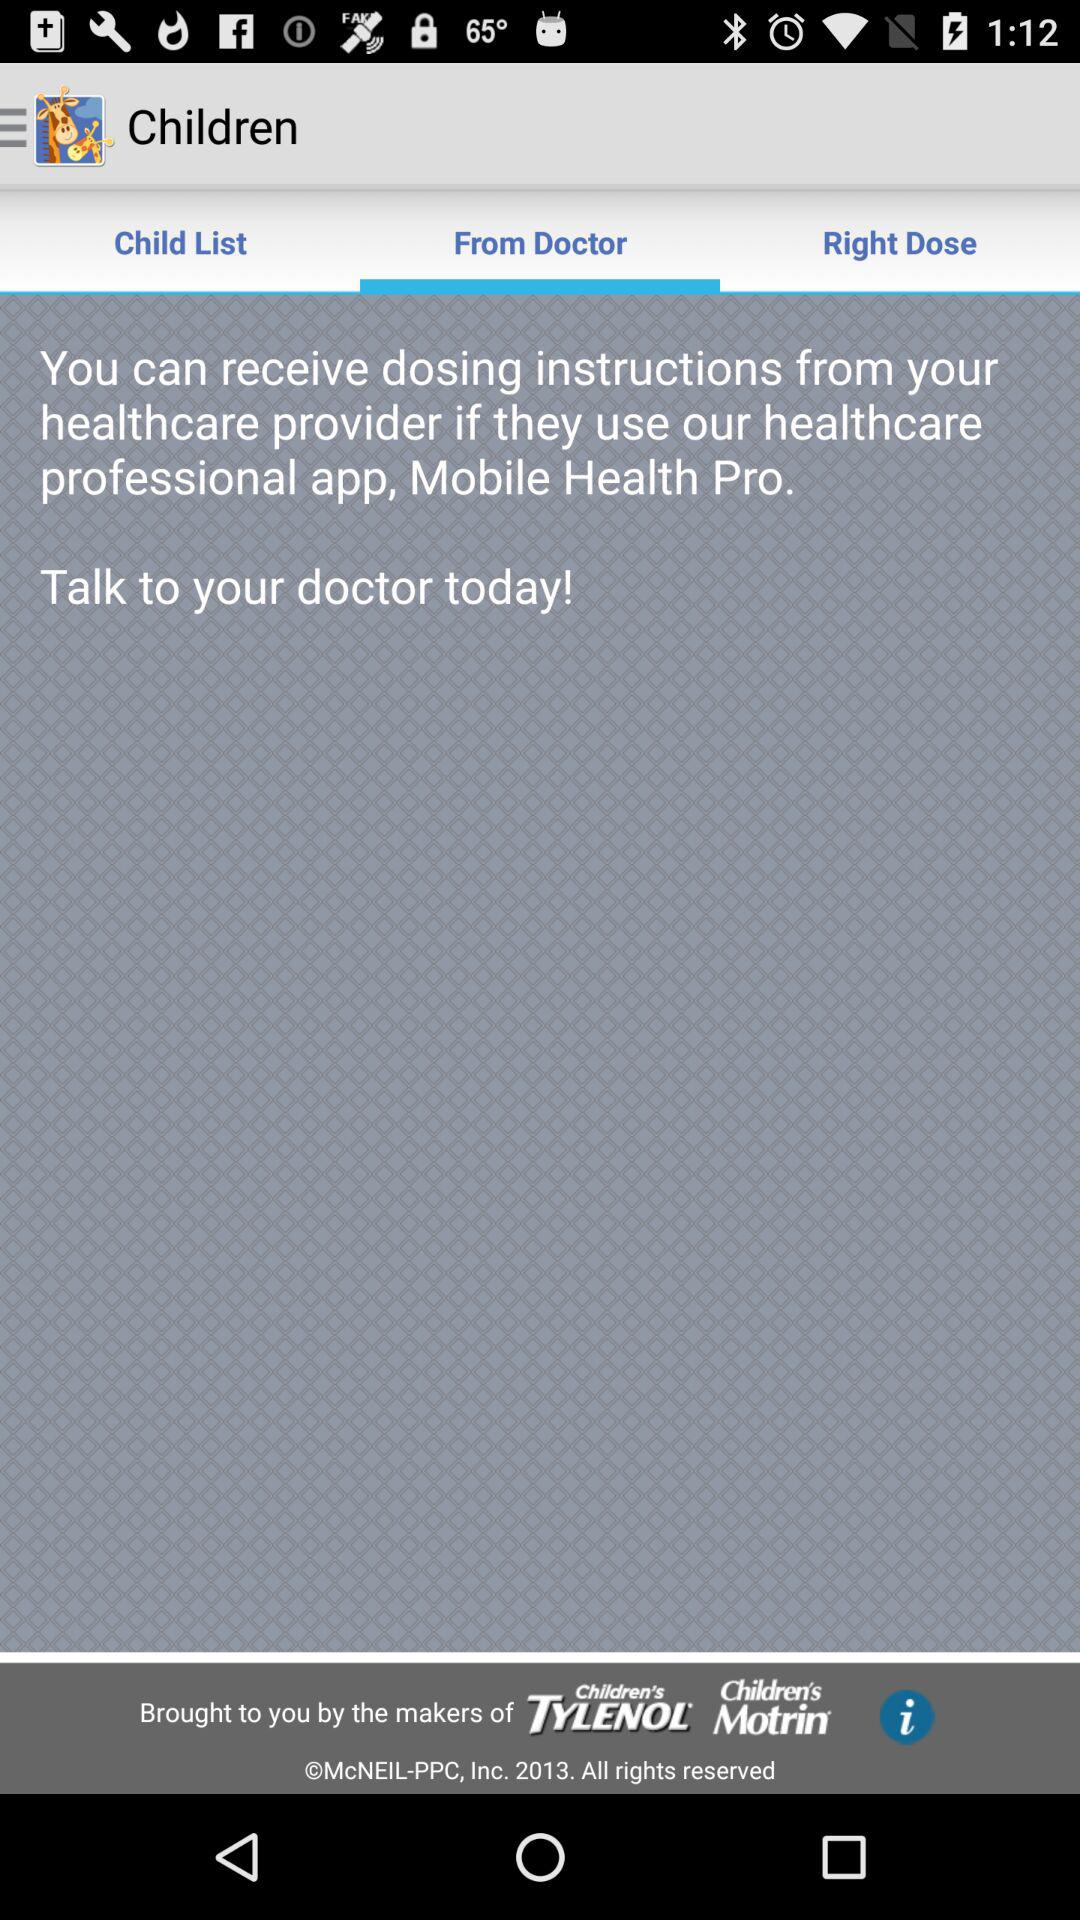Which tab is selected? The selected tab is "From Doctor". 